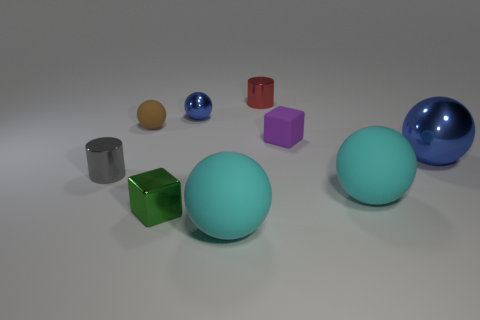What color is the cube that is made of the same material as the large blue sphere?
Provide a short and direct response. Green. Is the material of the tiny sphere to the left of the tiny blue sphere the same as the tiny cylinder that is behind the small purple rubber thing?
Your answer should be very brief. No. What is the size of the other metal sphere that is the same color as the tiny shiny ball?
Provide a short and direct response. Large. What is the material of the cylinder that is on the left side of the tiny green metallic thing?
Provide a succinct answer. Metal. Do the big cyan thing in front of the green cube and the blue thing that is behind the big blue metal sphere have the same shape?
Make the answer very short. Yes. There is a small ball that is the same color as the big metallic sphere; what is its material?
Give a very brief answer. Metal. Are there any large shiny balls?
Your response must be concise. Yes. There is a purple object that is the same shape as the small green thing; what is its material?
Make the answer very short. Rubber. There is a green cube; are there any matte things behind it?
Provide a succinct answer. Yes. Does the cyan sphere behind the green object have the same material as the red object?
Ensure brevity in your answer.  No. 